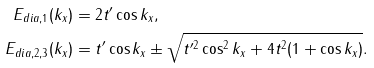Convert formula to latex. <formula><loc_0><loc_0><loc_500><loc_500>E _ { d i a , 1 } ( k _ { x } ) & = 2 t ^ { \prime } \cos k _ { x } , \\ E _ { d i a , 2 , 3 } ( k _ { x } ) & = t ^ { \prime } \cos { k _ { x } } \pm \sqrt { t ^ { \prime 2 } \cos ^ { 2 } { k _ { x } } + 4 t ^ { 2 } ( 1 + \cos { k _ { x } } ) } .</formula> 